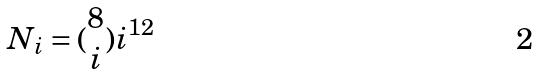Convert formula to latex. <formula><loc_0><loc_0><loc_500><loc_500>N _ { i } = ( \begin{matrix} 8 \\ i \end{matrix} ) i ^ { 1 2 }</formula> 